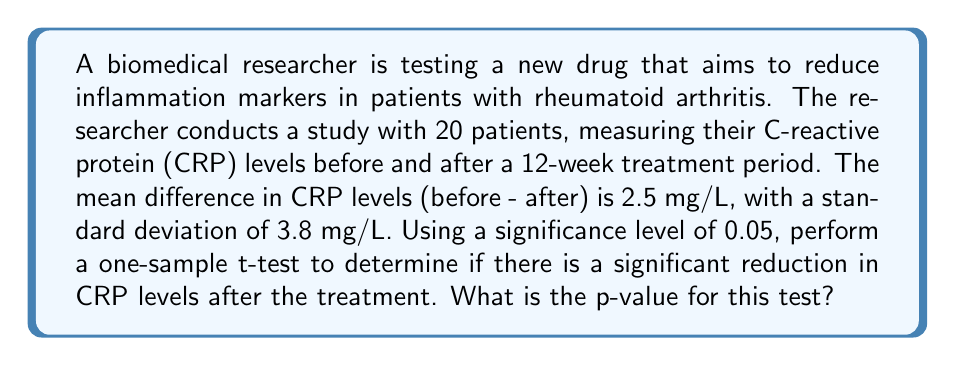Provide a solution to this math problem. To solve this problem, we'll follow these steps:

1. State the null and alternative hypotheses
2. Calculate the t-statistic
3. Determine the degrees of freedom
4. Find the p-value

Step 1: State the hypotheses
Null hypothesis ($H_0$): $\mu = 0$ (no difference in CRP levels)
Alternative hypothesis ($H_a$): $\mu > 0$ (CRP levels decreased after treatment)

Step 2: Calculate the t-statistic
The formula for the t-statistic in a one-sample t-test is:

$$ t = \frac{\bar{x} - \mu_0}{s / \sqrt{n}} $$

Where:
$\bar{x}$ = sample mean (2.5 mg/L)
$\mu_0$ = hypothesized population mean (0 mg/L)
$s$ = sample standard deviation (3.8 mg/L)
$n$ = sample size (20)

Plugging in the values:

$$ t = \frac{2.5 - 0}{3.8 / \sqrt{20}} = \frac{2.5}{3.8 / 4.472} = \frac{2.5}{0.849} = 2.944 $$

Step 3: Determine the degrees of freedom
Degrees of freedom (df) = n - 1 = 20 - 1 = 19

Step 4: Find the p-value
Using a t-distribution table or statistical software, we can find the p-value for a one-tailed test with t = 2.944 and df = 19.

The p-value is approximately 0.0041.

Since the p-value (0.0041) is less than the significance level (0.05), we reject the null hypothesis and conclude that there is a statistically significant reduction in CRP levels after the treatment.
Answer: The p-value for the one-sample t-test is approximately 0.0041. 